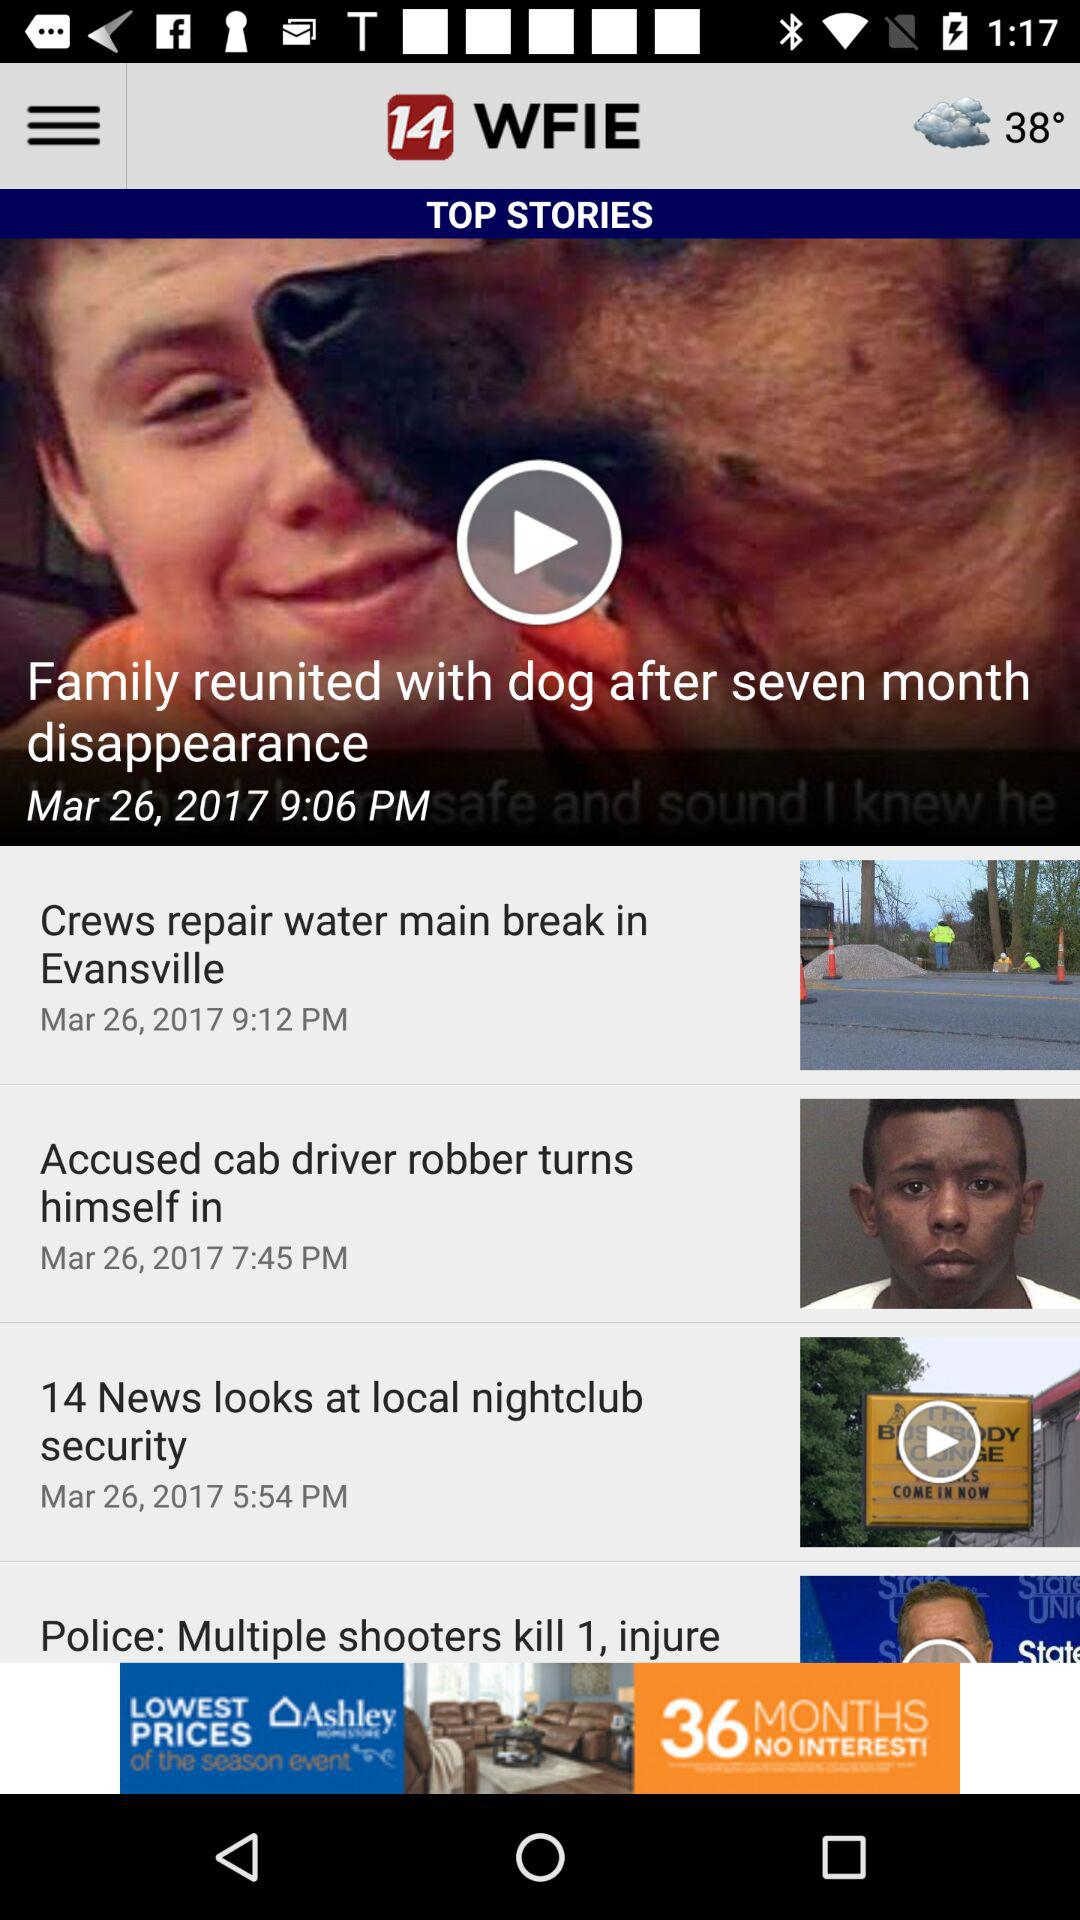What is the temperature shown on the screen? The temperature shown is 38°. 